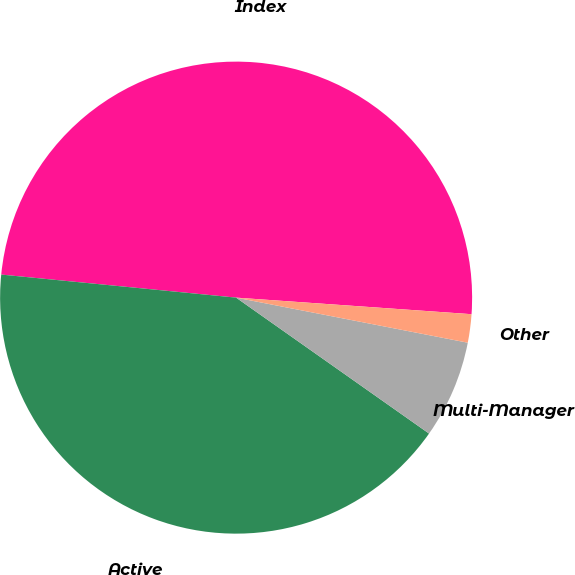Convert chart to OTSL. <chart><loc_0><loc_0><loc_500><loc_500><pie_chart><fcel>Index<fcel>Active<fcel>Multi-Manager<fcel>Other<nl><fcel>49.56%<fcel>41.79%<fcel>6.71%<fcel>1.94%<nl></chart> 